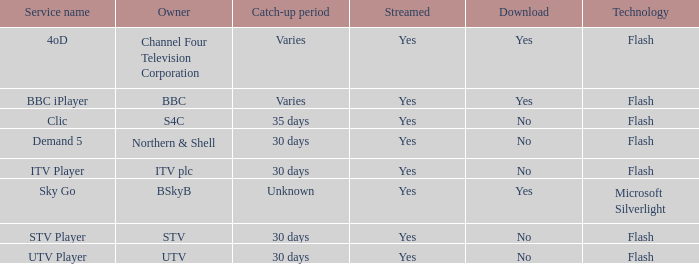What can be downloaded during the various catch-up phases? Yes, Yes. 